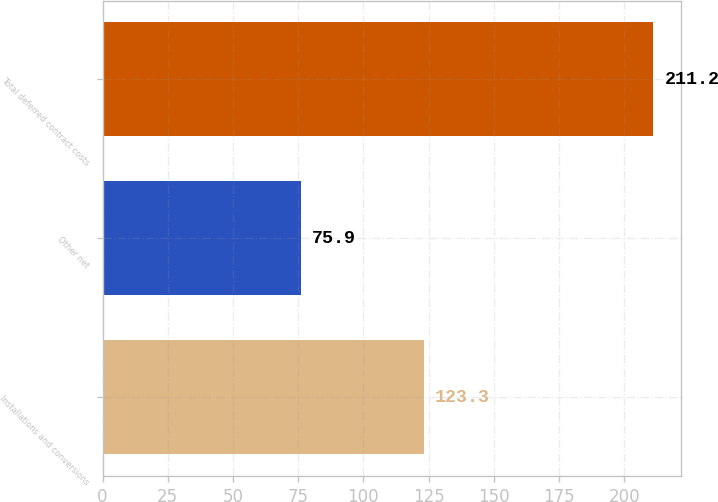Convert chart. <chart><loc_0><loc_0><loc_500><loc_500><bar_chart><fcel>Installations and conversions<fcel>Other net<fcel>Total deferred contract costs<nl><fcel>123.3<fcel>75.9<fcel>211.2<nl></chart> 